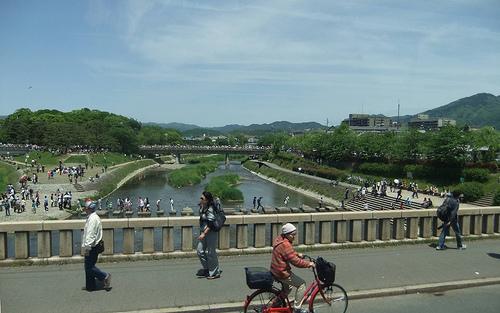How many people are on a bike?
Give a very brief answer. 1. 